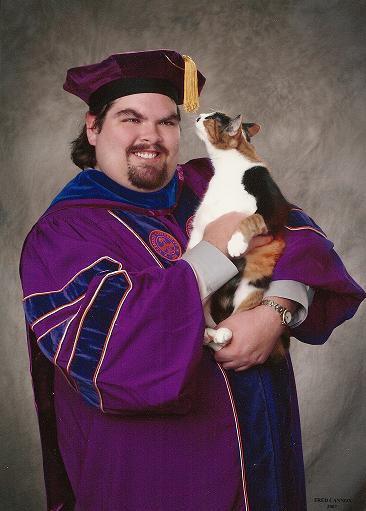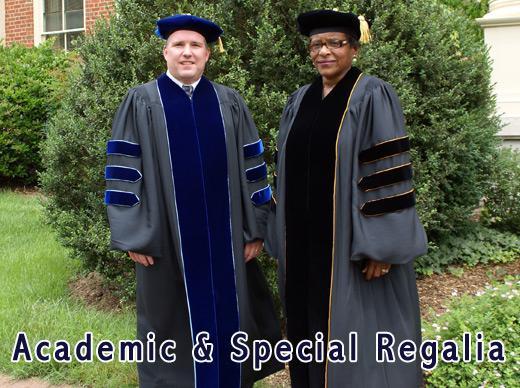The first image is the image on the left, the second image is the image on the right. Considering the images on both sides, is "Two people pose together outside wearing graduation attire in one of the images." valid? Answer yes or no. Yes. The first image is the image on the left, the second image is the image on the right. Assess this claim about the two images: "The left image shows a round-faced man with mustache and beard wearing a graduation robe and gold-tasseled cap, and the right image shows people in different colored robes with stripes on the sleeves.". Correct or not? Answer yes or no. Yes. 